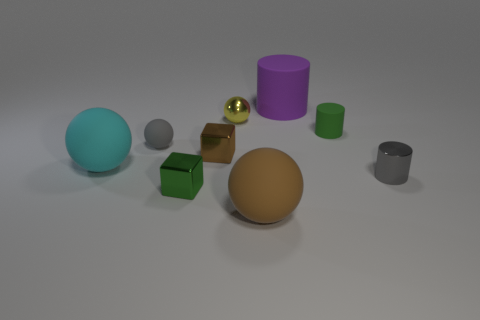What number of large matte objects are the same color as the small metal sphere? 0 